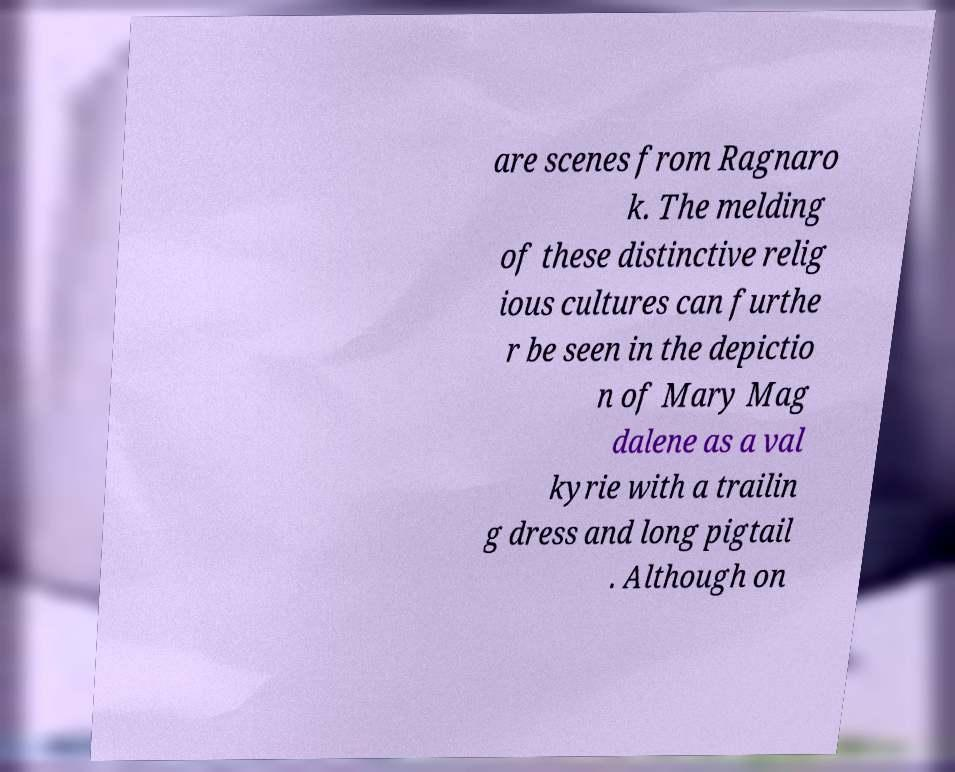Could you assist in decoding the text presented in this image and type it out clearly? are scenes from Ragnaro k. The melding of these distinctive relig ious cultures can furthe r be seen in the depictio n of Mary Mag dalene as a val kyrie with a trailin g dress and long pigtail . Although on 